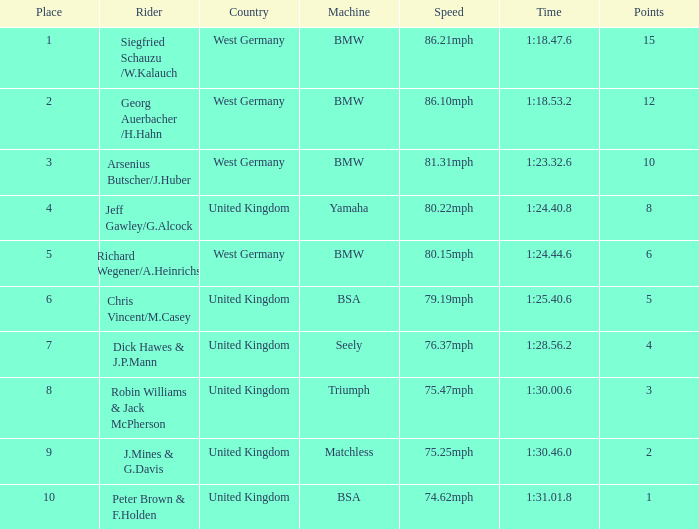Which place has points larger than 1, a bmw machine, and a time of 1:18.47.6? 1.0. 